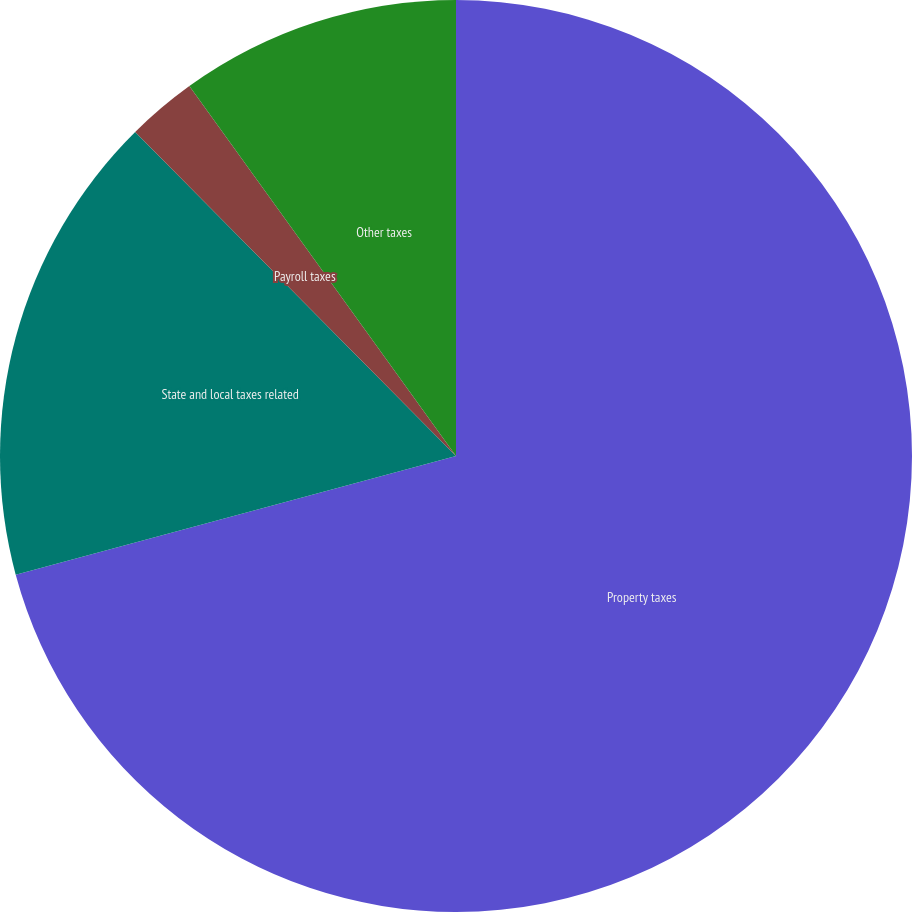Convert chart. <chart><loc_0><loc_0><loc_500><loc_500><pie_chart><fcel>Property taxes<fcel>State and local taxes related<fcel>Payroll taxes<fcel>Other taxes<nl><fcel>70.81%<fcel>16.77%<fcel>2.48%<fcel>9.94%<nl></chart> 